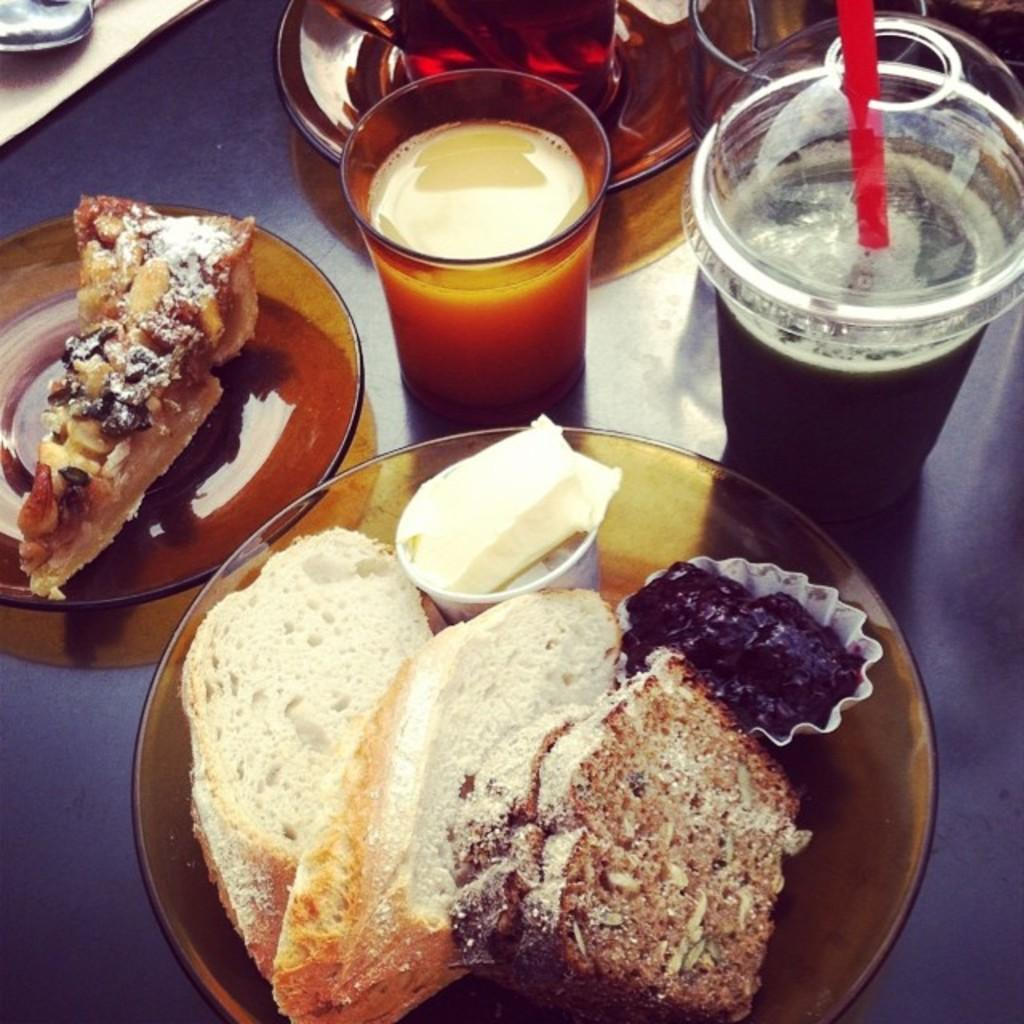What color is the table in the image? The table in the image is black. What food items are on the table? There are two plates containing cake on the table. What beverages are on the table? There is a glass containing milk and a glass containing a cool drink on the table. What additional tableware is on the table? There is a cup and saucer on the table. How many apples are in the nest on the table? There are no apples or nest present in the image; the table only contains plates with cake, glasses with milk and a cool drink, and a cup and saucer. 